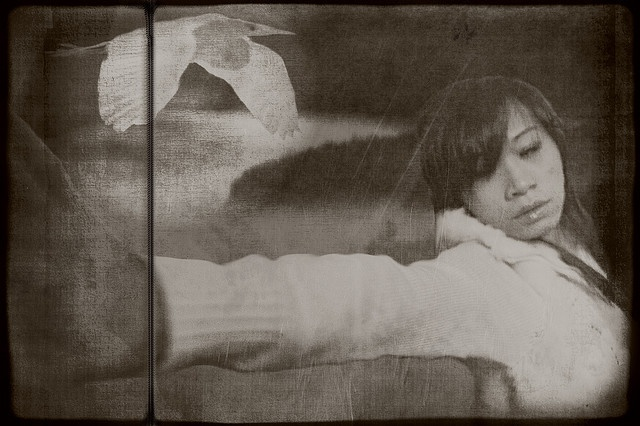Describe the objects in this image and their specific colors. I can see people in black, darkgray, and gray tones and bird in black, darkgray, and gray tones in this image. 